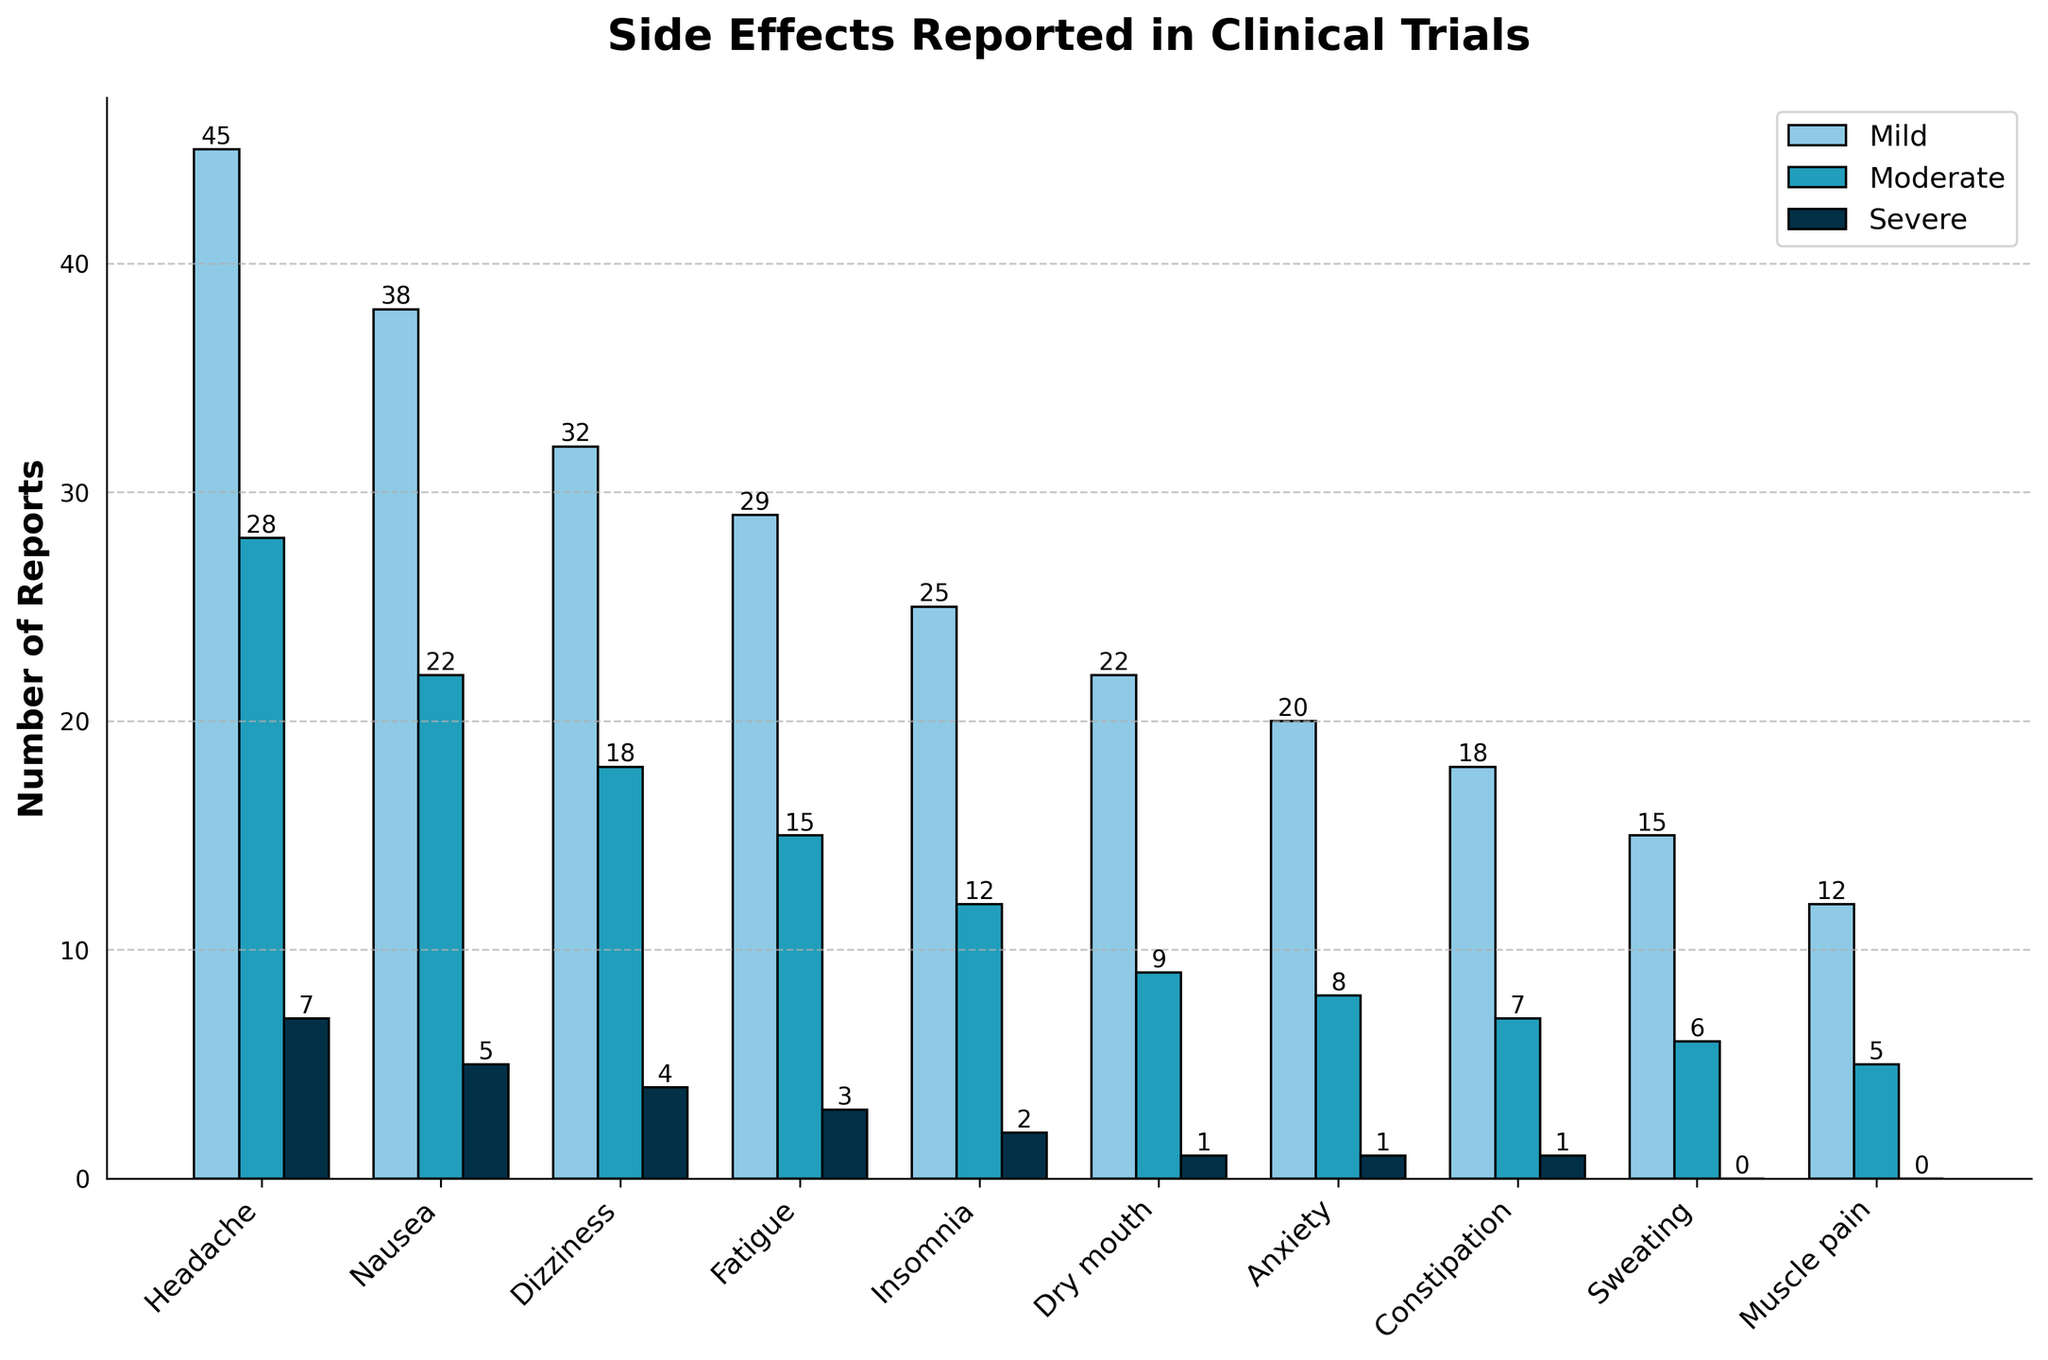What is the most frequently reported mild side effect? Compare the heights (lengths) of the "Mild" bars for all side effects. The tallest bar represents the most frequently reported mild side effect. The "Headache" bar is the tallest in the "Mild" category.
Answer: Headache Which side effect has the fewest severe reports? Compare the heights (lengths) of the "Severe" bars for all side effects. The shortest bar represents the side effect with the fewest severe reports. "Sweating" and "Muscle pain" both have the shortest bars in the "Severe" category, which is 0.
Answer: Sweating, Muscle pain How does the number of moderate Dizziness reports compare to moderate Nausea reports? Compare the heights (lengths) of the "Moderate" bars for "Dizziness" and "Nausea." The "Moderate" bar for "Dizziness" is shorter than that for "Nausea." Specifically, "Dizziness" has 18 moderate reports, whereas "Nausea" has 22.
Answer: Dizziness has fewer moderate reports than Nausea What is the total number of side effect reports for Fatigue across all severities? Add the heights (values) of the "Mild," "Moderate," and "Severe" bars for "Fatigue." The values are 29 (Mild) + 15 (Moderate) + 3 (Severe).
Answer: 47 Are there more severe reports for Anxiety or Dry mouth? Compare the heights (lengths) of the "Severe" bars for "Anxiety" and "Dry mouth." The "Severe" bar for both "Anxiety" and "Dry mouth" shows the same height, which is 1.
Answer: They are the same Which side effect has the highest total number of reports regardless of severity? Add the values of "Mild," "Moderate," and "Severe" for all side effects and compare the totals. "Headache" has the highest total with 45 + 28 + 7.
Answer: Headache Rank the side effects from most to least severe reports. Extract the "Severe" report counts for each side effect and rank them. The counts are: Headache (7), Nausea (5), Dizziness (4), Fatigue (3), Insomnia (2), Dry mouth (1), Anxiety (1), Constipation (1), Sweating (0), Muscle pain (0).
Answer: Headache > Nausea > Dizziness > Fatigue > Insomnia > Dry mouth = Anxiety = Constipation > Sweating = Muscle pain 